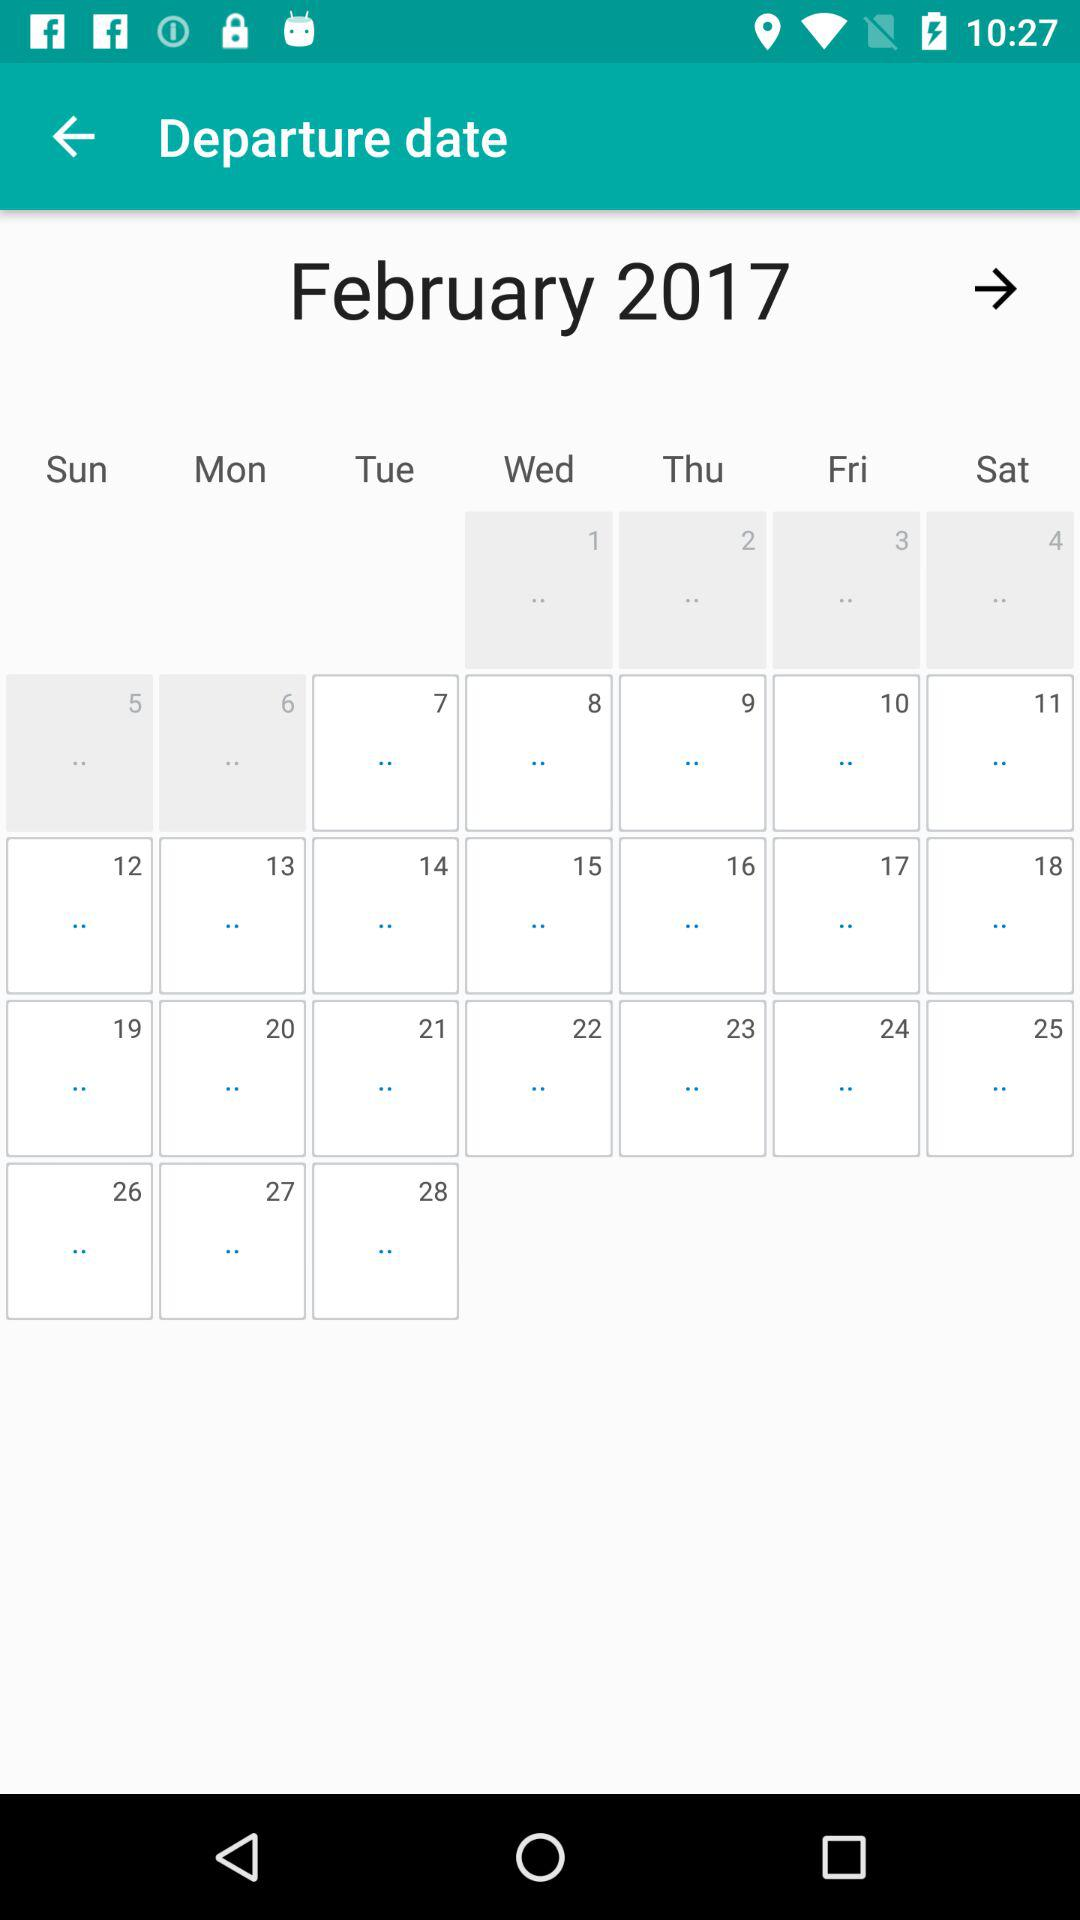How long is the journey?
When the provided information is insufficient, respond with <no answer>. <no answer> 